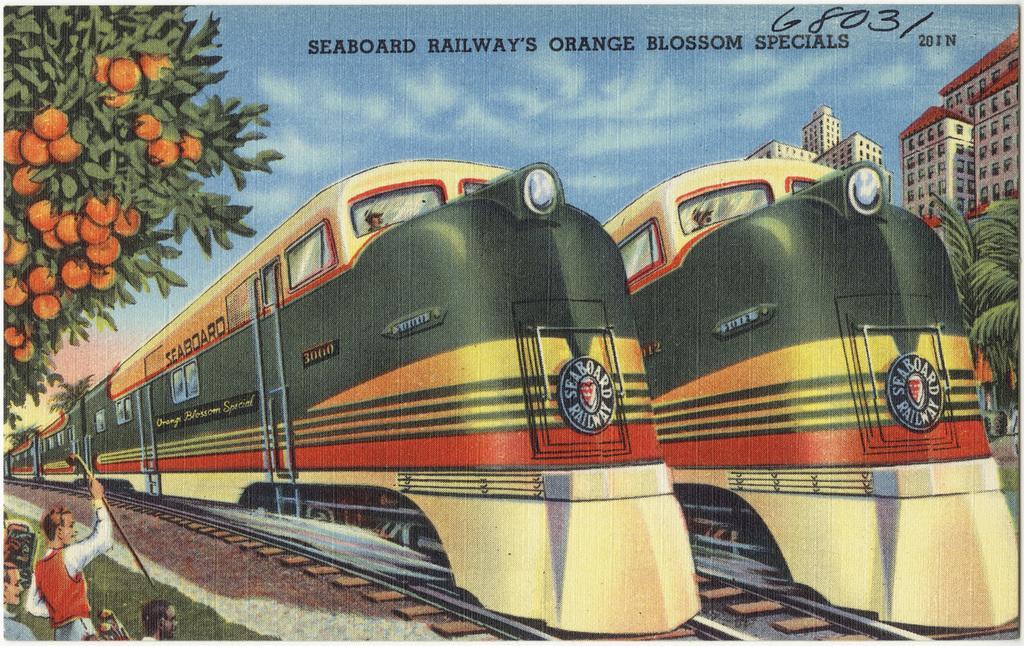Describe this image in one or two sentences. This is an image of the painting on which we can see there is a tree under that there are some people standing on the other side there is a building and tree. Also there is some text on the top of image. 